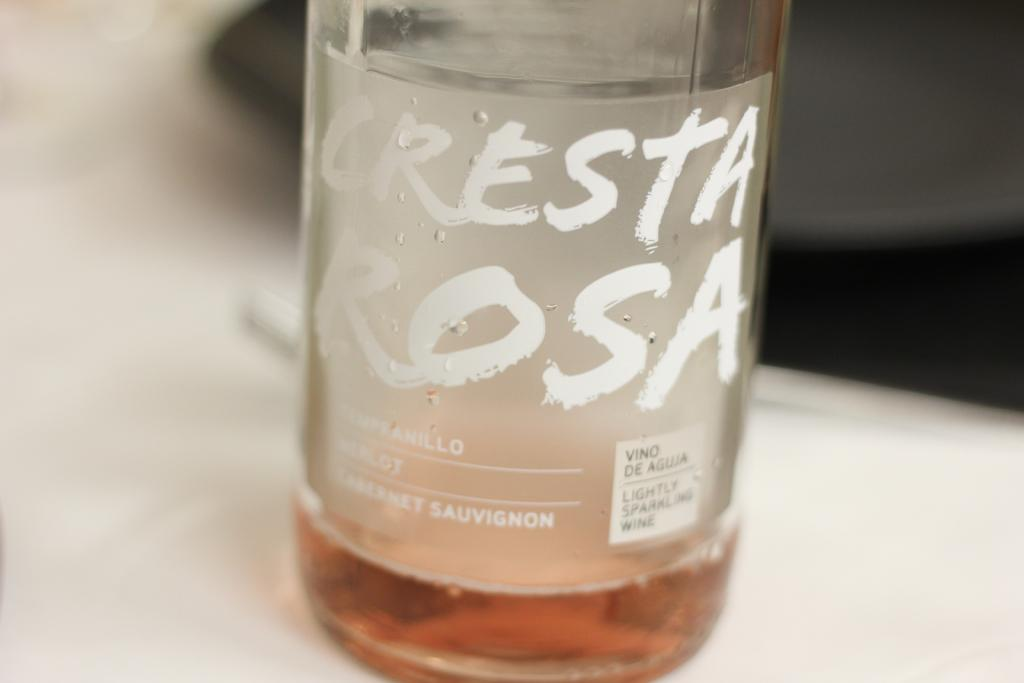<image>
Relay a brief, clear account of the picture shown. A bottle of Cresta Rosa is sitting on a table by a plate. 